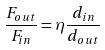<formula> <loc_0><loc_0><loc_500><loc_500>\frac { F _ { o u t } } { F _ { i n } } = \eta \frac { d _ { i n } } { d _ { o u t } }</formula> 